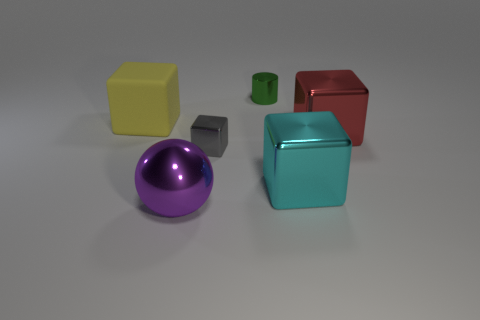How many yellow rubber objects are the same size as the purple ball?
Keep it short and to the point. 1. What material is the gray object?
Provide a short and direct response. Metal. Is the number of purple things greater than the number of tiny cyan cylinders?
Ensure brevity in your answer.  Yes. Does the gray thing have the same shape as the yellow thing?
Offer a very short reply. Yes. Is there anything else that has the same shape as the purple thing?
Your answer should be very brief. No. Do the big shiny object left of the tiny green cylinder and the big block that is on the left side of the small cylinder have the same color?
Your response must be concise. No. Are there fewer red shiny objects that are in front of the cyan object than large objects in front of the green cylinder?
Make the answer very short. Yes. The big metal object that is left of the big cyan block has what shape?
Your answer should be compact. Sphere. What number of other things are made of the same material as the small green cylinder?
Provide a short and direct response. 4. Does the large yellow matte object have the same shape as the small metallic object that is in front of the small metal cylinder?
Provide a succinct answer. Yes. 